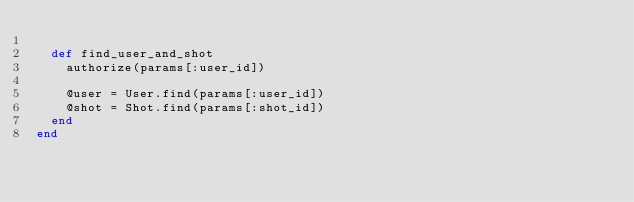Convert code to text. <code><loc_0><loc_0><loc_500><loc_500><_Ruby_>
  def find_user_and_shot
    authorize(params[:user_id])

    @user = User.find(params[:user_id])
    @shot = Shot.find(params[:shot_id])
  end
end
</code> 